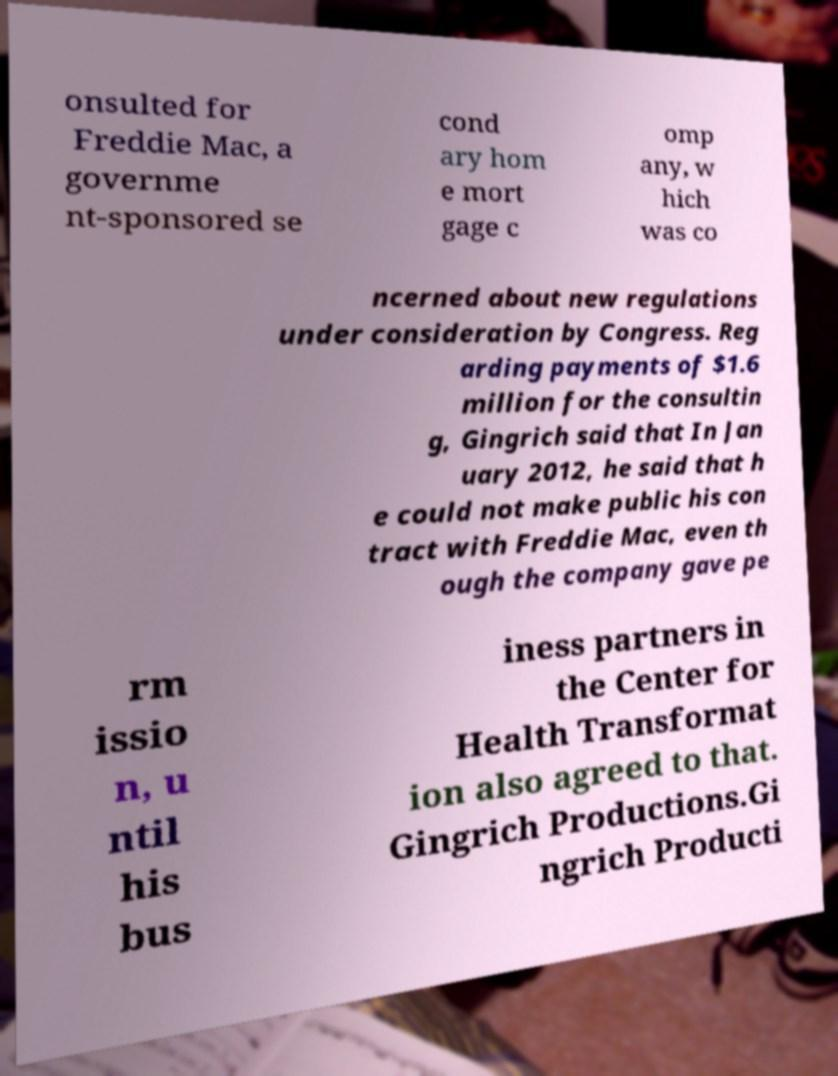Can you accurately transcribe the text from the provided image for me? onsulted for Freddie Mac, a governme nt-sponsored se cond ary hom e mort gage c omp any, w hich was co ncerned about new regulations under consideration by Congress. Reg arding payments of $1.6 million for the consultin g, Gingrich said that In Jan uary 2012, he said that h e could not make public his con tract with Freddie Mac, even th ough the company gave pe rm issio n, u ntil his bus iness partners in the Center for Health Transformat ion also agreed to that. Gingrich Productions.Gi ngrich Producti 